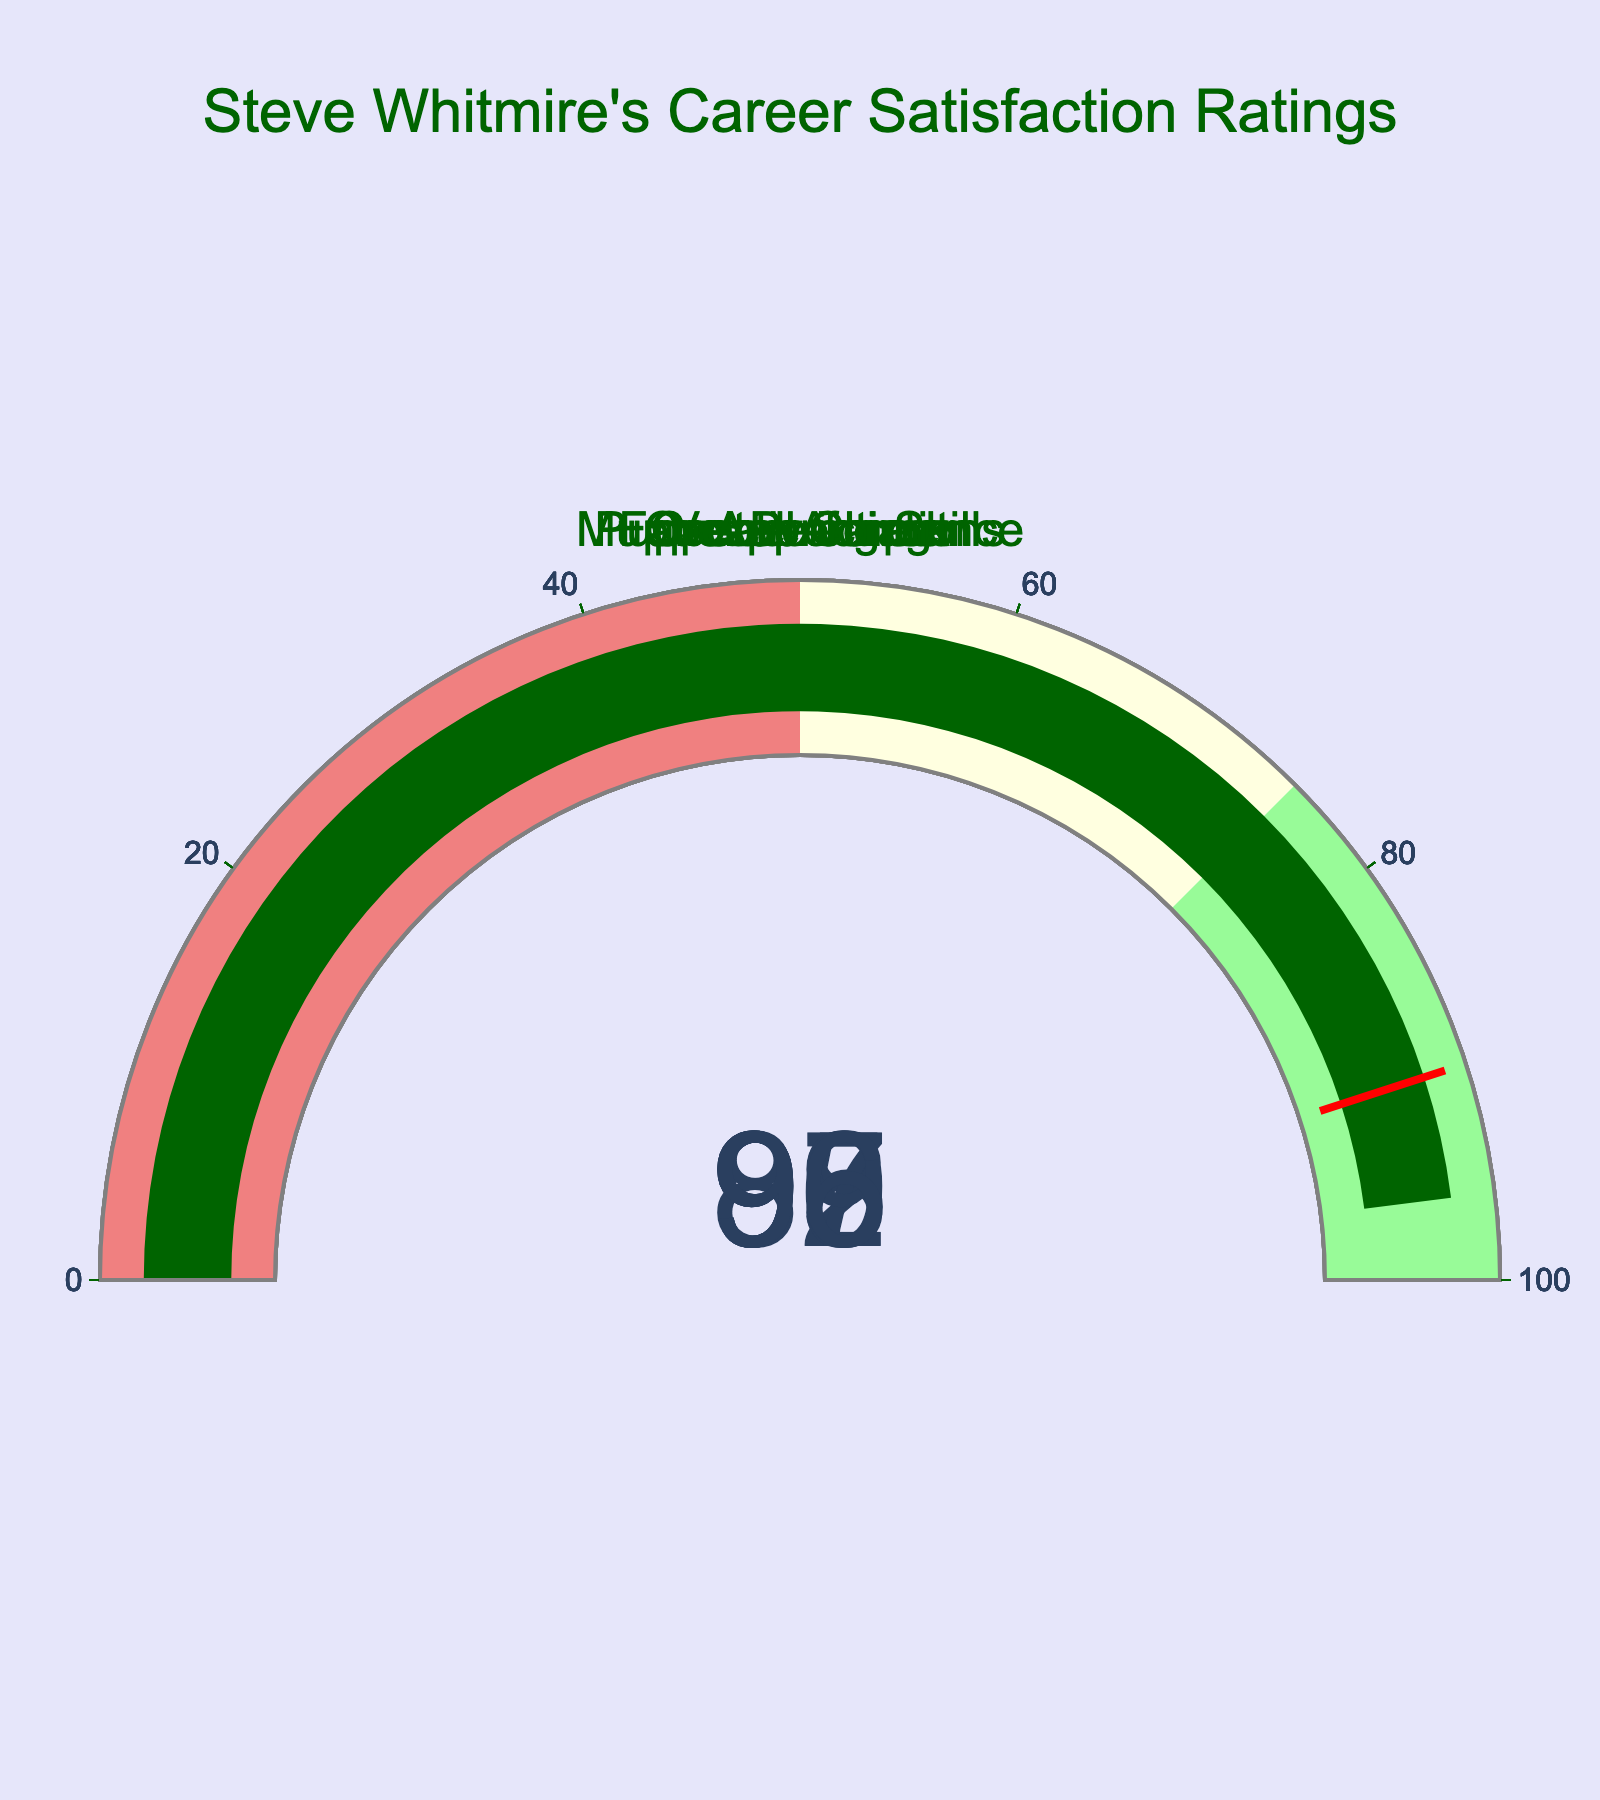What is the title of the figure? The title is displayed prominently at the top of the figure. It reads "Steve Whitmire's Career Satisfaction Ratings".
Answer: Steve Whitmire's Career Satisfaction Ratings What is the satisfaction rating for Muppet Performance? The Muppet Performance gauge shows the satisfaction rating value of 98.
Answer: 98 Which career aspect has the lowest satisfaction rating? By examining each gauge, the Creative Input gauge has the lowest satisfaction rating at 89.
Answer: Creative Input How many career aspects are evaluated in the figure? The figure displays six separate gauges, each representing a different career aspect.
Answer: 6 What is the difference between the highest and lowest satisfaction ratings shown in the figure? The highest rating is 98 (Muppet Performance), and the lowest is 89 (Creative Input). The difference is 98 - 89.
Answer: 9 Which career aspects have a satisfaction rating above 95? The gauges for Overall Career, Muppet Performance, Puppeteering Skills, and Fan Appreciation show ratings above 95.
Answer: Overall Career, Muppet Performance, Puppeteering Skills, Fan Appreciation What is the average satisfaction rating for all career aspects? Sum all the satisfaction ratings: 95 + 98 + 92 + 97 + 89 + 96 = 567. Divide by the number of career aspects: 567 / 6.
Answer: 94.5 How many career aspects have satisfaction ratings below the threshold of 90? Creative Input is the only gauge with a satisfaction rating below 90.
Answer: 1 Which career aspect received the second-highest satisfaction rating? The second-highest rating after Muppet Performance (98) is Puppeteering Skills at 97.
Answer: Puppeteering Skills 